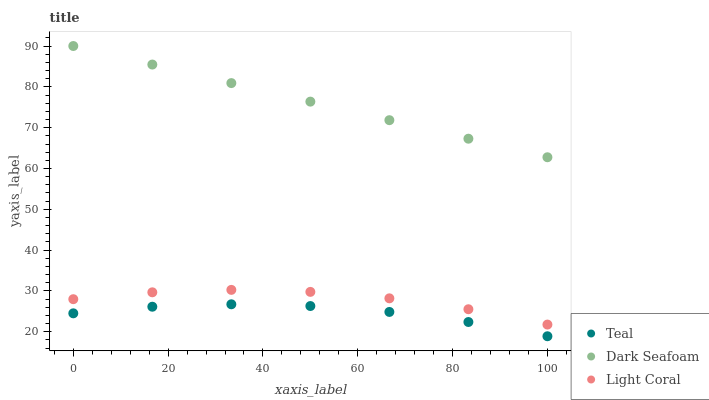Does Teal have the minimum area under the curve?
Answer yes or no. Yes. Does Dark Seafoam have the maximum area under the curve?
Answer yes or no. Yes. Does Dark Seafoam have the minimum area under the curve?
Answer yes or no. No. Does Teal have the maximum area under the curve?
Answer yes or no. No. Is Dark Seafoam the smoothest?
Answer yes or no. Yes. Is Light Coral the roughest?
Answer yes or no. Yes. Is Teal the smoothest?
Answer yes or no. No. Is Teal the roughest?
Answer yes or no. No. Does Teal have the lowest value?
Answer yes or no. Yes. Does Dark Seafoam have the lowest value?
Answer yes or no. No. Does Dark Seafoam have the highest value?
Answer yes or no. Yes. Does Teal have the highest value?
Answer yes or no. No. Is Teal less than Dark Seafoam?
Answer yes or no. Yes. Is Dark Seafoam greater than Light Coral?
Answer yes or no. Yes. Does Teal intersect Dark Seafoam?
Answer yes or no. No. 